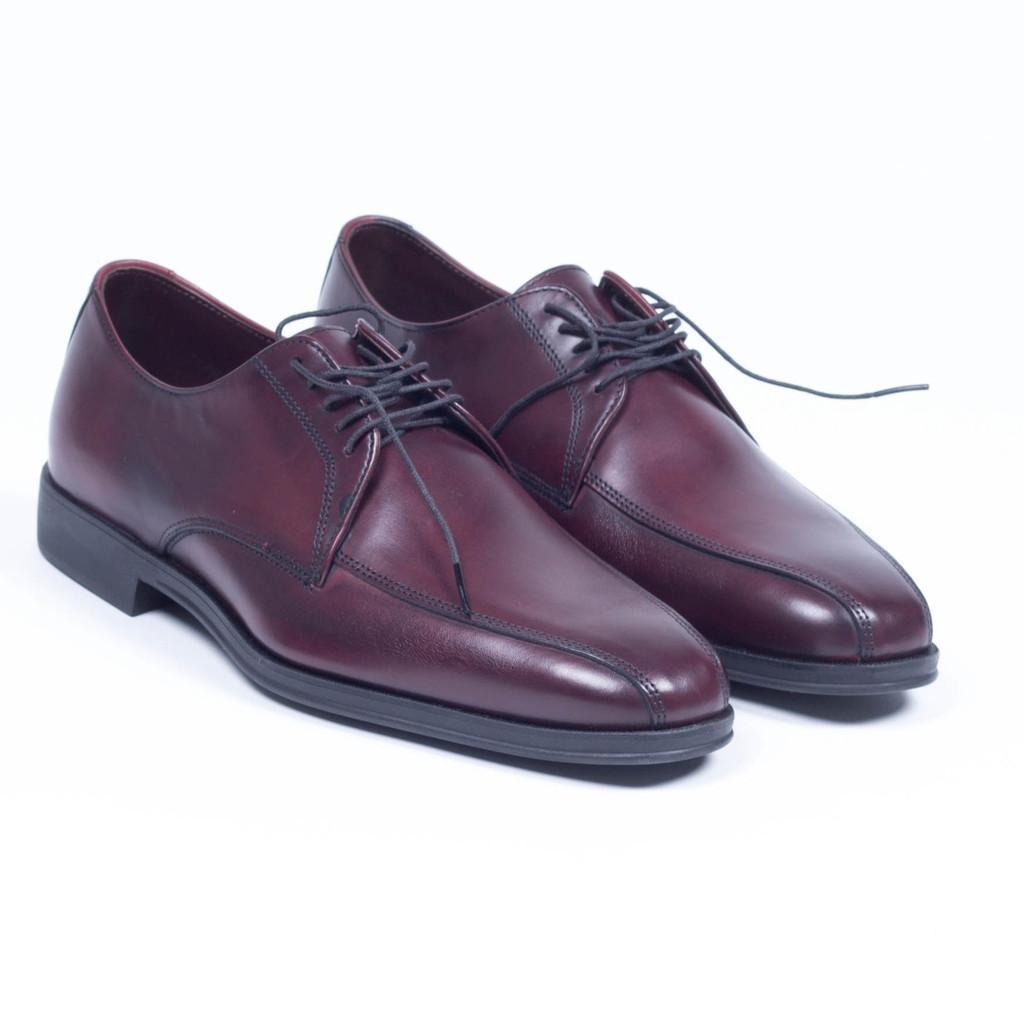Can you describe this image briefly? In this picture we can see leather shoes, there is a white color background. 